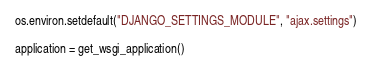Convert code to text. <code><loc_0><loc_0><loc_500><loc_500><_Python_>os.environ.setdefault("DJANGO_SETTINGS_MODULE", "ajax.settings")

application = get_wsgi_application()
</code> 